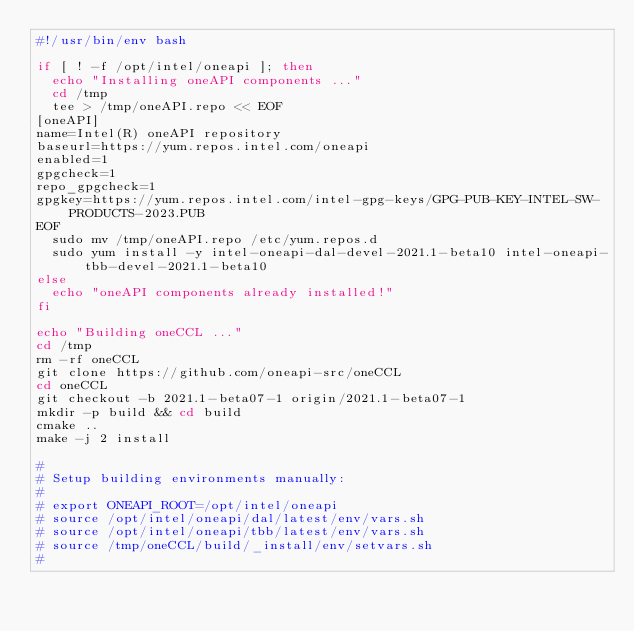Convert code to text. <code><loc_0><loc_0><loc_500><loc_500><_Bash_>#!/usr/bin/env bash

if [ ! -f /opt/intel/oneapi ]; then
  echo "Installing oneAPI components ..."
  cd /tmp
  tee > /tmp/oneAPI.repo << EOF
[oneAPI]
name=Intel(R) oneAPI repository
baseurl=https://yum.repos.intel.com/oneapi
enabled=1
gpgcheck=1
repo_gpgcheck=1
gpgkey=https://yum.repos.intel.com/intel-gpg-keys/GPG-PUB-KEY-INTEL-SW-PRODUCTS-2023.PUB
EOF
  sudo mv /tmp/oneAPI.repo /etc/yum.repos.d
  sudo yum install -y intel-oneapi-dal-devel-2021.1-beta10 intel-oneapi-tbb-devel-2021.1-beta10
else
  echo "oneAPI components already installed!"
fi  

echo "Building oneCCL ..."
cd /tmp
rm -rf oneCCL
git clone https://github.com/oneapi-src/oneCCL
cd oneCCL
git checkout -b 2021.1-beta07-1 origin/2021.1-beta07-1
mkdir -p build && cd build
cmake ..
make -j 2 install

#
# Setup building environments manually:
#
# export ONEAPI_ROOT=/opt/intel/oneapi
# source /opt/intel/oneapi/dal/latest/env/vars.sh
# source /opt/intel/oneapi/tbb/latest/env/vars.sh
# source /tmp/oneCCL/build/_install/env/setvars.sh
#
</code> 